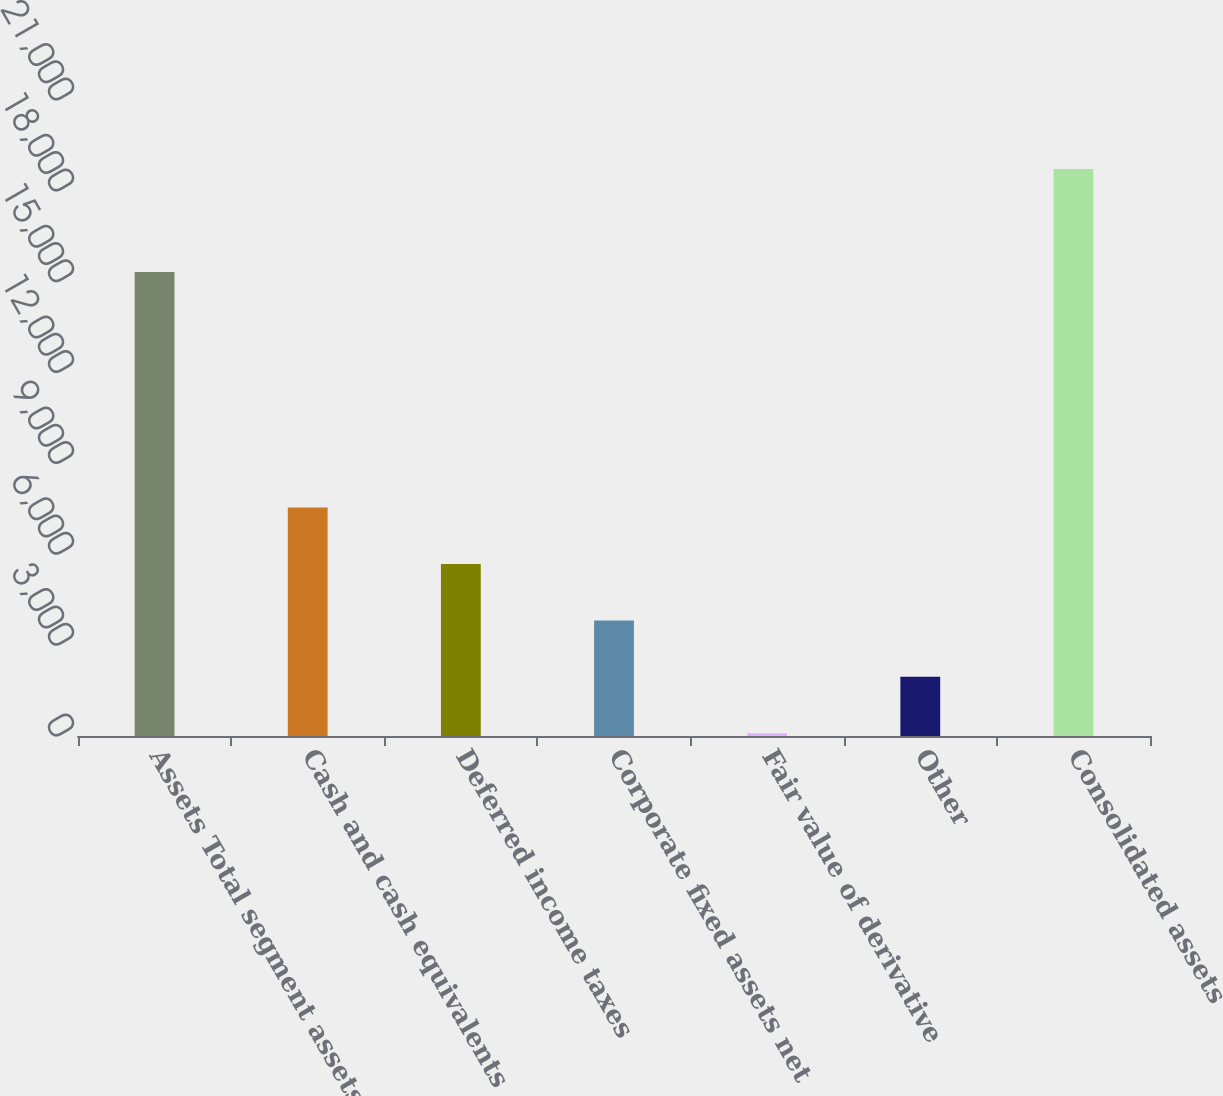<chart> <loc_0><loc_0><loc_500><loc_500><bar_chart><fcel>Assets Total segment assets<fcel>Cash and cash equivalents<fcel>Deferred income taxes<fcel>Corporate fixed assets net<fcel>Fair value of derivative<fcel>Other<fcel>Consolidated assets<nl><fcel>15321<fcel>7541.8<fcel>5679.1<fcel>3816.4<fcel>91<fcel>1953.7<fcel>18718<nl></chart> 